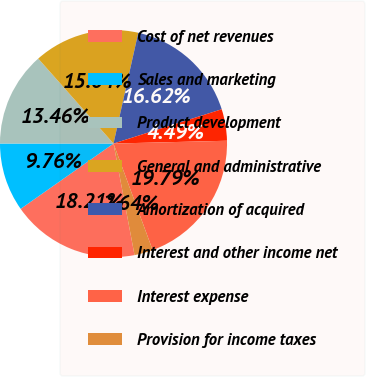Convert chart. <chart><loc_0><loc_0><loc_500><loc_500><pie_chart><fcel>Cost of net revenues<fcel>Sales and marketing<fcel>Product development<fcel>General and administrative<fcel>Amortization of acquired<fcel>Interest and other income net<fcel>Interest expense<fcel>Provision for income taxes<nl><fcel>18.21%<fcel>9.76%<fcel>13.46%<fcel>15.04%<fcel>16.62%<fcel>4.49%<fcel>19.79%<fcel>2.64%<nl></chart> 